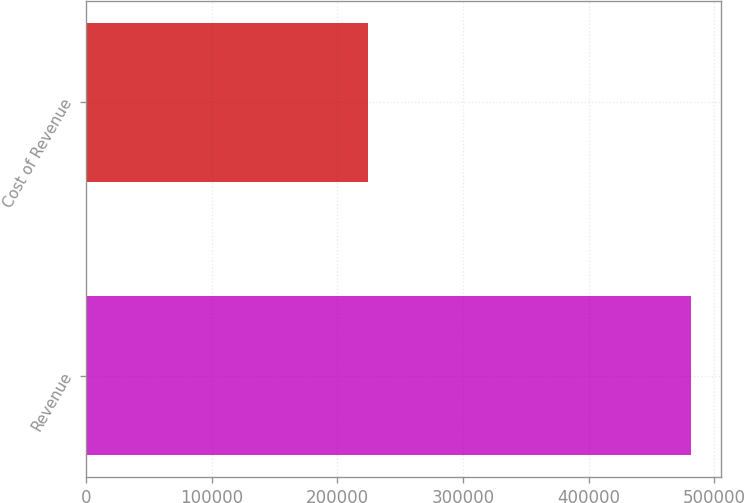Convert chart. <chart><loc_0><loc_0><loc_500><loc_500><bar_chart><fcel>Revenue<fcel>Cost of Revenue<nl><fcel>481625<fcel>224214<nl></chart> 